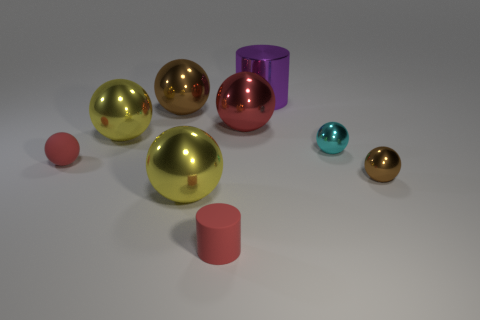Are there fewer tiny cyan objects to the right of the tiny cyan shiny ball than things?
Provide a short and direct response. Yes. Is there a shiny sphere that has the same color as the rubber cylinder?
Ensure brevity in your answer.  Yes. There is a big red metallic thing; does it have the same shape as the brown thing right of the big cylinder?
Offer a very short reply. Yes. Are there any red spheres that have the same material as the tiny brown ball?
Offer a very short reply. Yes. There is a metallic object that is behind the brown thing on the left side of the big red shiny thing; is there a yellow object that is to the left of it?
Give a very brief answer. Yes. How many other things are there of the same shape as the big red object?
Keep it short and to the point. 6. There is a large thing in front of the brown metallic ball that is to the right of the cylinder in front of the big red metallic object; what is its color?
Offer a terse response. Yellow. What number of red rubber cylinders are there?
Offer a terse response. 1. How many small objects are either red matte things or metal things?
Make the answer very short. 4. There is a red rubber thing that is the same size as the matte sphere; what is its shape?
Provide a succinct answer. Cylinder. 